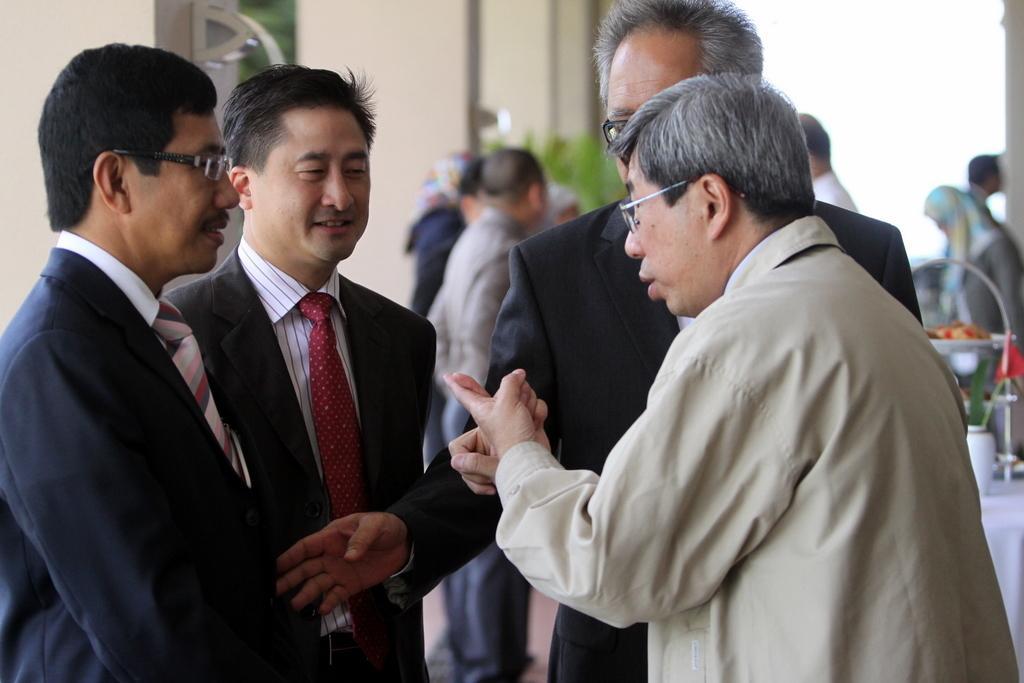Can you describe this image briefly? In the image I can see some people, among them there are wearing suits and behind there are some other people and a plant. 